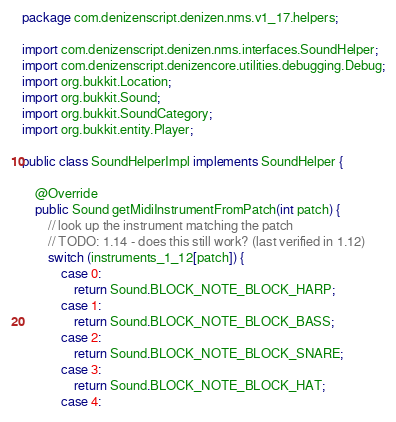<code> <loc_0><loc_0><loc_500><loc_500><_Java_>package com.denizenscript.denizen.nms.v1_17.helpers;

import com.denizenscript.denizen.nms.interfaces.SoundHelper;
import com.denizenscript.denizencore.utilities.debugging.Debug;
import org.bukkit.Location;
import org.bukkit.Sound;
import org.bukkit.SoundCategory;
import org.bukkit.entity.Player;

public class SoundHelperImpl implements SoundHelper {

    @Override
    public Sound getMidiInstrumentFromPatch(int patch) {
        // look up the instrument matching the patch
        // TODO: 1.14 - does this still work? (last verified in 1.12)
        switch (instruments_1_12[patch]) {
            case 0:
                return Sound.BLOCK_NOTE_BLOCK_HARP;
            case 1:
                return Sound.BLOCK_NOTE_BLOCK_BASS;
            case 2:
                return Sound.BLOCK_NOTE_BLOCK_SNARE;
            case 3:
                return Sound.BLOCK_NOTE_BLOCK_HAT;
            case 4:</code> 